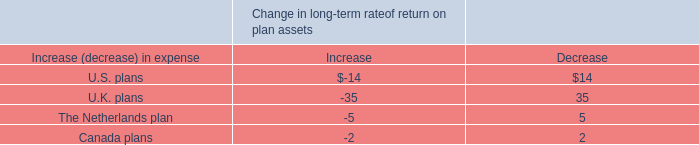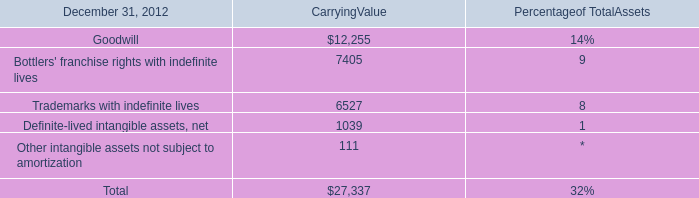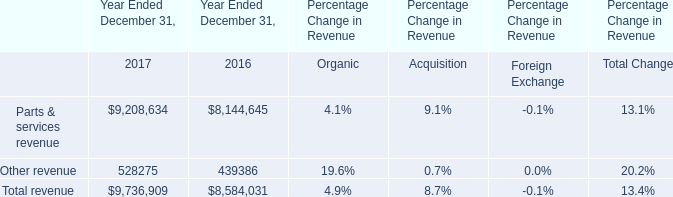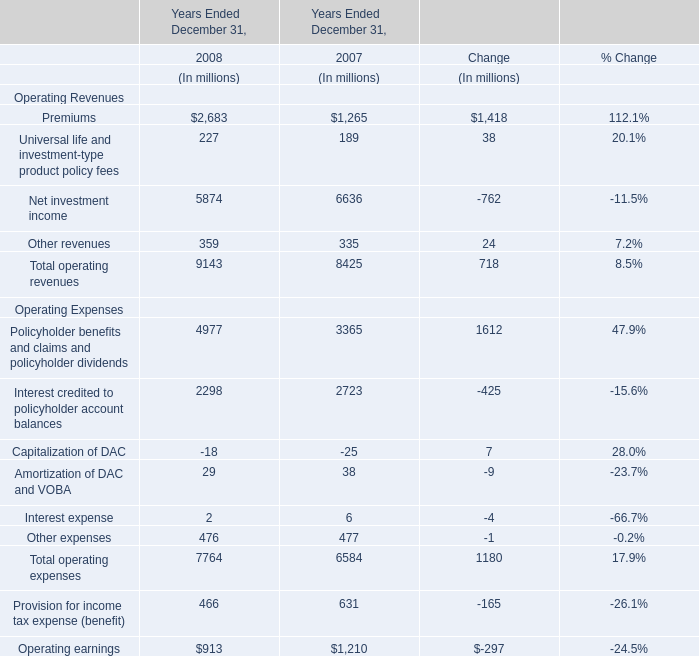what was the percentage change in the goodwill in 2010 as a result of the hewitt acquisition . 
Computations: ((8.6 - 6.1) / 6.1)
Answer: 0.40984. 